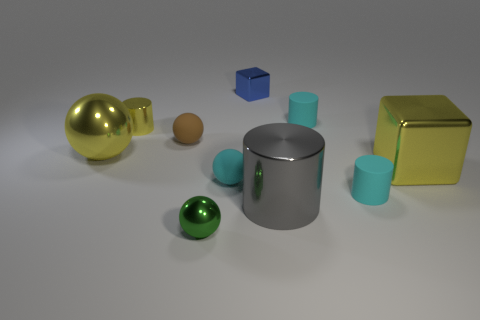Subtract 3 cylinders. How many cylinders are left? 1 Subtract all gray cylinders. How many cylinders are left? 3 Add 3 matte spheres. How many matte spheres exist? 5 Subtract all cyan cylinders. How many cylinders are left? 2 Subtract 1 cyan balls. How many objects are left? 9 Subtract all blocks. How many objects are left? 8 Subtract all green balls. Subtract all red cylinders. How many balls are left? 3 Subtract all green blocks. How many cyan cylinders are left? 2 Subtract all blue shiny objects. Subtract all cyan metal spheres. How many objects are left? 9 Add 4 large yellow shiny blocks. How many large yellow shiny blocks are left? 5 